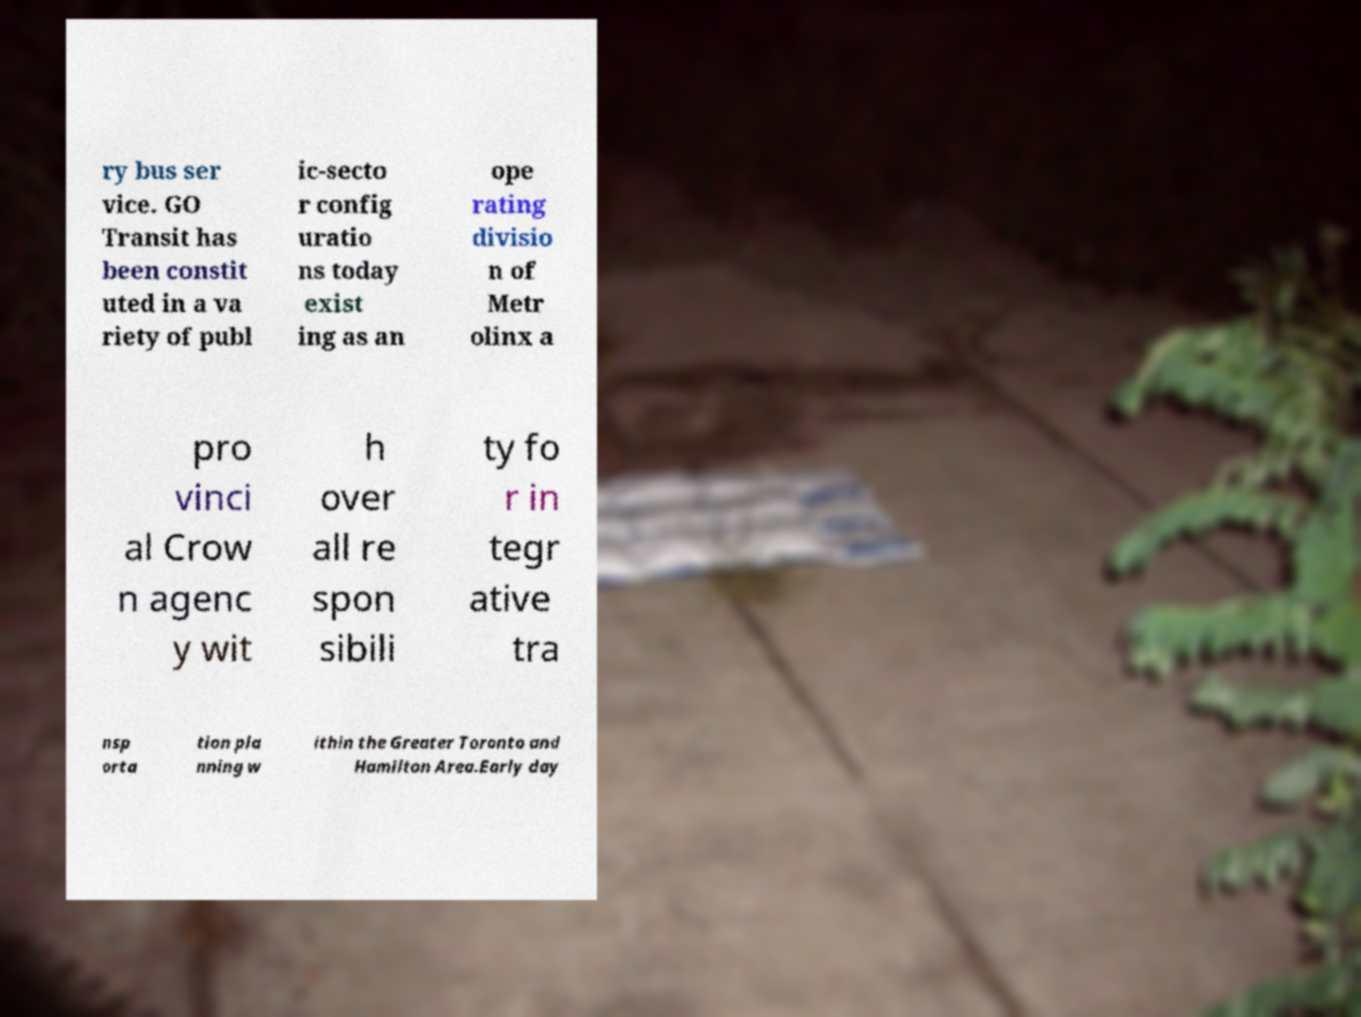There's text embedded in this image that I need extracted. Can you transcribe it verbatim? ry bus ser vice. GO Transit has been constit uted in a va riety of publ ic-secto r config uratio ns today exist ing as an ope rating divisio n of Metr olinx a pro vinci al Crow n agenc y wit h over all re spon sibili ty fo r in tegr ative tra nsp orta tion pla nning w ithin the Greater Toronto and Hamilton Area.Early day 